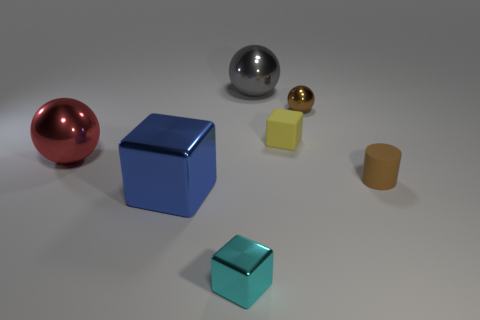Subtract all tiny blocks. How many blocks are left? 1 Add 1 tiny purple matte cylinders. How many objects exist? 8 Subtract all balls. How many objects are left? 4 Subtract all large gray rubber objects. Subtract all small metal spheres. How many objects are left? 6 Add 7 blue shiny cubes. How many blue shiny cubes are left? 8 Add 7 tiny yellow matte things. How many tiny yellow matte things exist? 8 Subtract 0 yellow balls. How many objects are left? 7 